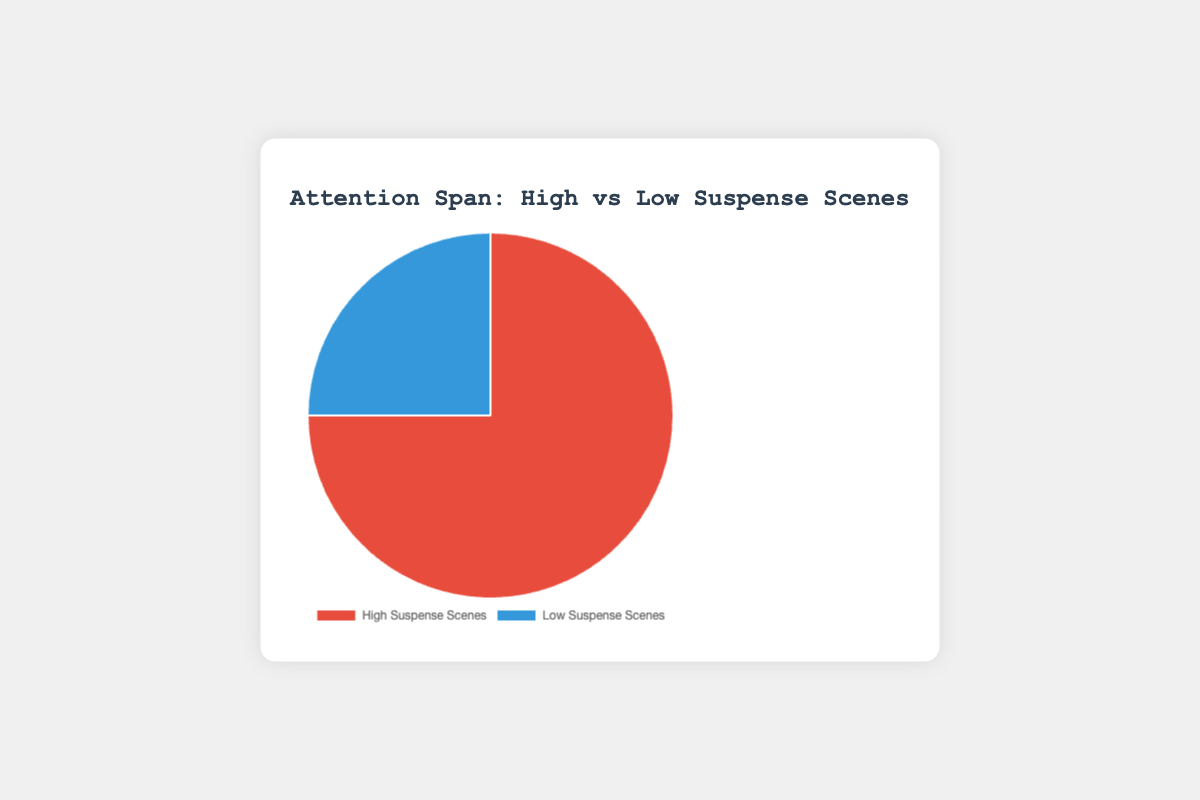What percentage of attention span is attributed to High Suspense Scenes? The figure shows two parts of the pie, and the High Suspense Scenes section is labeled. According to the chart, this section accounts for 75% of the attention span.
Answer: 75% How much larger is the attention span for High Suspense Scenes compared to Low Suspense Scenes? To find how much larger the attention span for High Suspense Scenes is compared to Low Suspense Scenes, you subtract the percentage of Low Suspense Scenes from High Suspense Scenes: 75% - 25% = 50%.
Answer: 50% What is the attention span percentage for Low Suspense Scenes? The figure shows two parts of the pie, and the Low Suspense Scenes section is labeled. According to the chart, this section accounts for 25% of the attention span.
Answer: 25% Which type of scene has a higher attention span? By comparing the two labeled sections of the pie chart, you can see that High Suspense Scenes have a higher attention span percentage (75%) compared to Low Suspense Scenes (25%).
Answer: High Suspense Scenes If the total attention span was 100 units, how many units would correspond to Low Suspense Scenes? Given that Low Suspense Scenes account for 25% of the attention span, you can calculate the units by multiplying 25% by 100 units, which equals 25 units.
Answer: 25 units What percentage of the whole does the red section of the pie represent? The red section of the pie chart represents the High Suspense Scenes. According to the chart, this section accounts for 75% of the entire pie.
Answer: 75% If the attention span for each scene type was a circle's area, which section would have the larger area? The larger area would depend on the percentage each section represents. High Suspense Scenes account for 75%, while Low Suspense Scenes account for 25%, so the section for High Suspense Scenes would have the larger area.
Answer: High Suspense Scenes What is the total attention span percentage represented in the pie chart? The total pie chart represents the full 100% of the attention span. The percentages given (75% for High Suspense Scenes and 25% for Low Suspense Scenes) should sum up to 100%.
Answer: 100% Calculate the ratio of attention span between High Suspense and Low Suspense Scenes. The attention span percentage for High Suspense Scenes is 75%, and for Low Suspense Scenes is 25%. The ratio is then 75:25, which simplifies to 3:1.
Answer: 3:1 Which section of the pie chart is colored blue, and what does it represent? The blue section of the pie chart represents the Low Suspense Scenes, as seen in the legend and the chart labels.
Answer: Low Suspense Scenes 